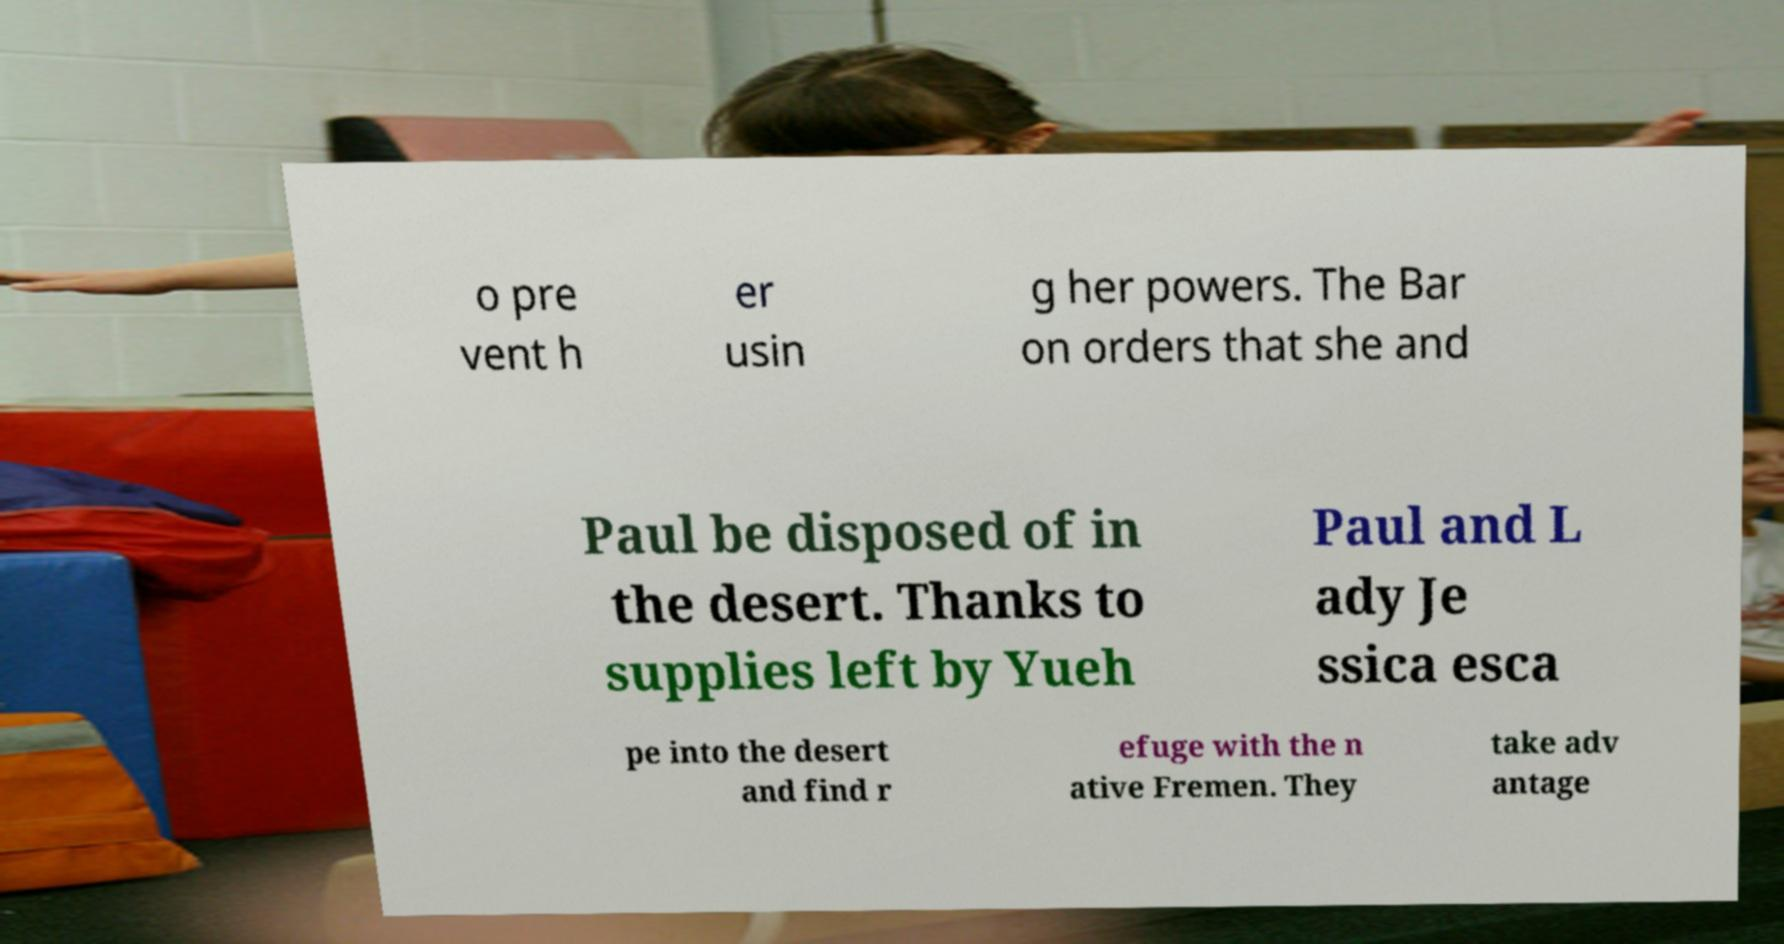Please read and relay the text visible in this image. What does it say? o pre vent h er usin g her powers. The Bar on orders that she and Paul be disposed of in the desert. Thanks to supplies left by Yueh Paul and L ady Je ssica esca pe into the desert and find r efuge with the n ative Fremen. They take adv antage 